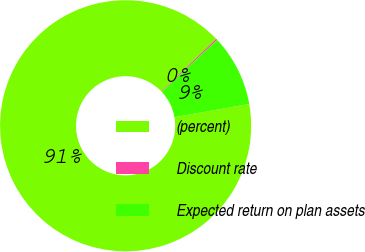Convert chart. <chart><loc_0><loc_0><loc_500><loc_500><pie_chart><fcel>(percent)<fcel>Discount rate<fcel>Expected return on plan assets<nl><fcel>90.59%<fcel>0.18%<fcel>9.22%<nl></chart> 